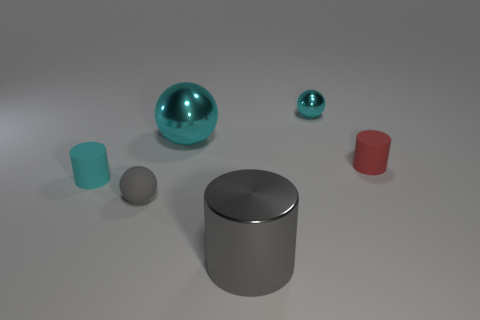There is a cyan thing that is made of the same material as the red object; what is its size?
Your response must be concise. Small. Do the large gray object and the metallic object to the left of the gray cylinder have the same shape?
Your answer should be very brief. No. What is the size of the metallic cylinder?
Ensure brevity in your answer.  Large. Is the number of tiny cylinders right of the cyan cylinder less than the number of large purple matte spheres?
Give a very brief answer. No. What number of brown rubber things have the same size as the cyan matte thing?
Ensure brevity in your answer.  0. The metal object that is the same color as the large ball is what shape?
Give a very brief answer. Sphere. Does the tiny cylinder that is to the left of the gray cylinder have the same color as the small sphere that is behind the gray rubber ball?
Your response must be concise. Yes. What number of tiny matte cylinders are right of the small cyan sphere?
Your answer should be very brief. 1. There is a metallic thing that is the same color as the small matte sphere; what is its size?
Offer a terse response. Large. Is there a small gray object of the same shape as the small cyan matte thing?
Ensure brevity in your answer.  No. 